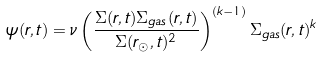Convert formula to latex. <formula><loc_0><loc_0><loc_500><loc_500>\psi ( r , t ) = \nu \left ( \frac { \Sigma ( r , t ) \Sigma _ { g a s } ( r , t ) } { \Sigma ( r _ { \odot } , t ) ^ { 2 } } \right ) ^ { ( k - 1 ) } \Sigma _ { g a s } ( r , t ) ^ { k }</formula> 